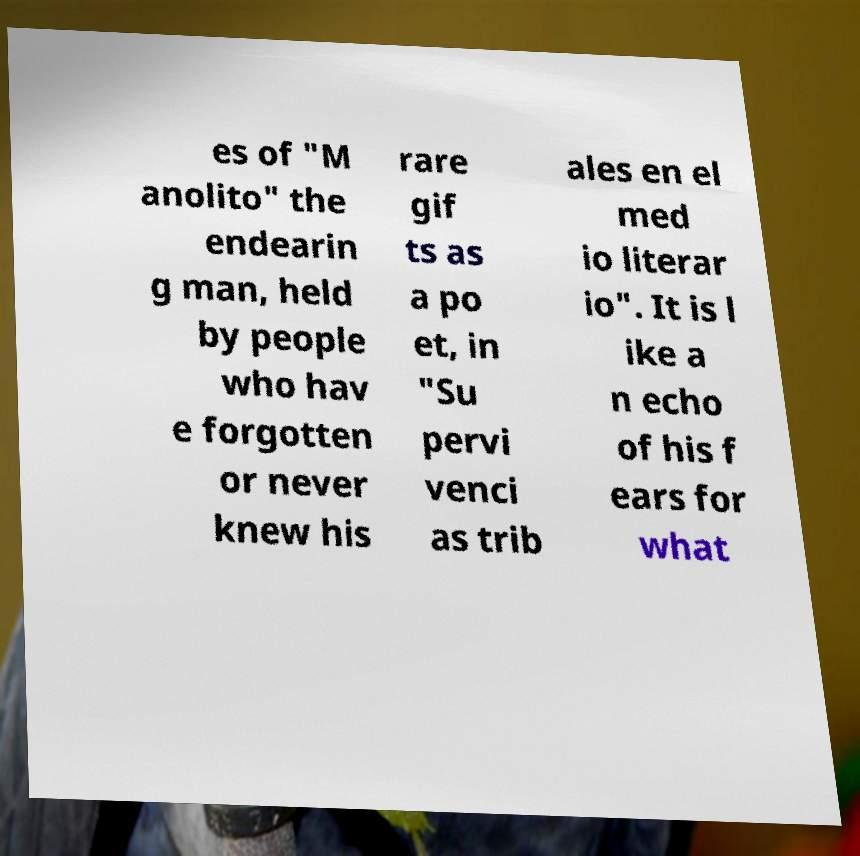Please identify and transcribe the text found in this image. es of "M anolito" the endearin g man, held by people who hav e forgotten or never knew his rare gif ts as a po et, in "Su pervi venci as trib ales en el med io literar io". It is l ike a n echo of his f ears for what 